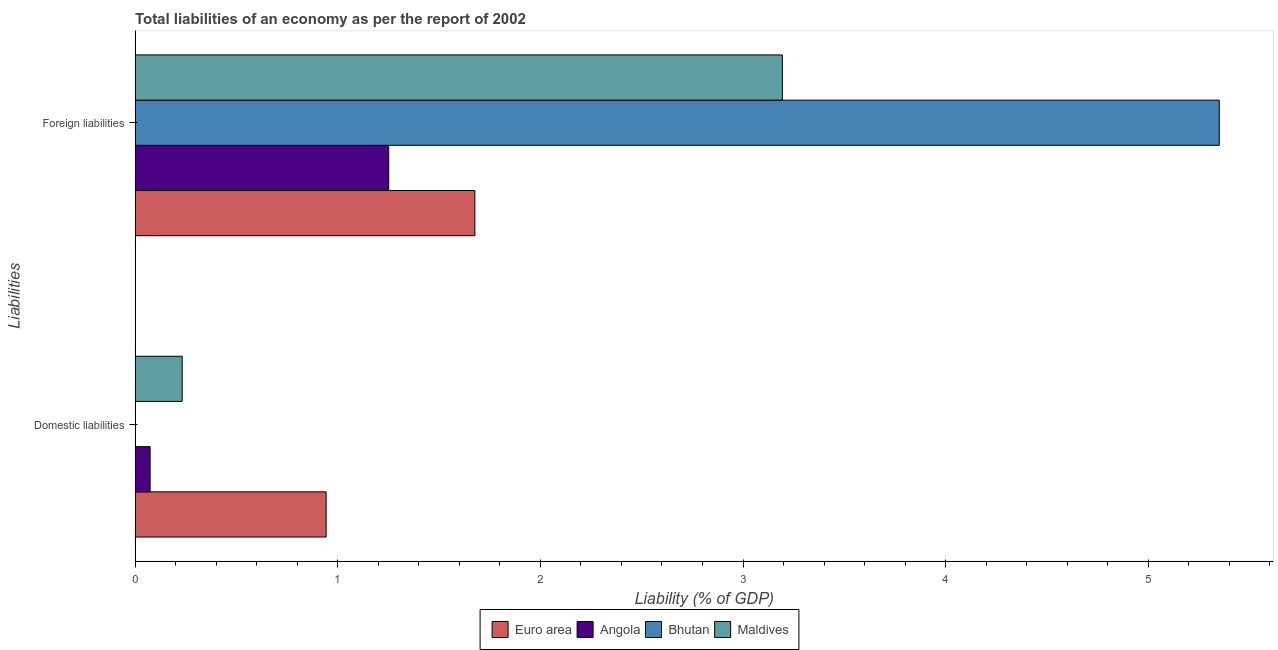Are the number of bars on each tick of the Y-axis equal?
Offer a terse response. No. What is the label of the 2nd group of bars from the top?
Your response must be concise. Domestic liabilities. What is the incurrence of foreign liabilities in Bhutan?
Your answer should be very brief. 5.35. Across all countries, what is the maximum incurrence of foreign liabilities?
Provide a succinct answer. 5.35. Across all countries, what is the minimum incurrence of foreign liabilities?
Ensure brevity in your answer.  1.25. In which country was the incurrence of foreign liabilities maximum?
Your answer should be compact. Bhutan. What is the total incurrence of foreign liabilities in the graph?
Your answer should be compact. 11.47. What is the difference between the incurrence of foreign liabilities in Bhutan and that in Maldives?
Provide a short and direct response. 2.16. What is the difference between the incurrence of domestic liabilities in Maldives and the incurrence of foreign liabilities in Bhutan?
Offer a terse response. -5.12. What is the average incurrence of foreign liabilities per country?
Make the answer very short. 2.87. What is the difference between the incurrence of domestic liabilities and incurrence of foreign liabilities in Angola?
Your answer should be very brief. -1.18. In how many countries, is the incurrence of domestic liabilities greater than 3.4 %?
Offer a very short reply. 0. What is the ratio of the incurrence of foreign liabilities in Bhutan to that in Angola?
Your answer should be very brief. 4.27. In how many countries, is the incurrence of domestic liabilities greater than the average incurrence of domestic liabilities taken over all countries?
Provide a short and direct response. 1. Are the values on the major ticks of X-axis written in scientific E-notation?
Your answer should be compact. No. Does the graph contain any zero values?
Offer a terse response. Yes. Where does the legend appear in the graph?
Provide a succinct answer. Bottom center. How many legend labels are there?
Provide a short and direct response. 4. What is the title of the graph?
Offer a terse response. Total liabilities of an economy as per the report of 2002. Does "Tanzania" appear as one of the legend labels in the graph?
Your answer should be very brief. No. What is the label or title of the X-axis?
Give a very brief answer. Liability (% of GDP). What is the label or title of the Y-axis?
Offer a very short reply. Liabilities. What is the Liability (% of GDP) of Euro area in Domestic liabilities?
Provide a succinct answer. 0.94. What is the Liability (% of GDP) in Angola in Domestic liabilities?
Give a very brief answer. 0.07. What is the Liability (% of GDP) of Bhutan in Domestic liabilities?
Offer a terse response. 0. What is the Liability (% of GDP) in Maldives in Domestic liabilities?
Your answer should be compact. 0.23. What is the Liability (% of GDP) of Euro area in Foreign liabilities?
Offer a terse response. 1.68. What is the Liability (% of GDP) of Angola in Foreign liabilities?
Keep it short and to the point. 1.25. What is the Liability (% of GDP) of Bhutan in Foreign liabilities?
Offer a very short reply. 5.35. What is the Liability (% of GDP) in Maldives in Foreign liabilities?
Offer a terse response. 3.19. Across all Liabilities, what is the maximum Liability (% of GDP) in Euro area?
Make the answer very short. 1.68. Across all Liabilities, what is the maximum Liability (% of GDP) of Angola?
Give a very brief answer. 1.25. Across all Liabilities, what is the maximum Liability (% of GDP) in Bhutan?
Give a very brief answer. 5.35. Across all Liabilities, what is the maximum Liability (% of GDP) of Maldives?
Provide a short and direct response. 3.19. Across all Liabilities, what is the minimum Liability (% of GDP) of Euro area?
Ensure brevity in your answer.  0.94. Across all Liabilities, what is the minimum Liability (% of GDP) in Angola?
Give a very brief answer. 0.07. Across all Liabilities, what is the minimum Liability (% of GDP) of Bhutan?
Offer a very short reply. 0. Across all Liabilities, what is the minimum Liability (% of GDP) in Maldives?
Provide a succinct answer. 0.23. What is the total Liability (% of GDP) in Euro area in the graph?
Give a very brief answer. 2.62. What is the total Liability (% of GDP) of Angola in the graph?
Provide a short and direct response. 1.33. What is the total Liability (% of GDP) in Bhutan in the graph?
Keep it short and to the point. 5.35. What is the total Liability (% of GDP) of Maldives in the graph?
Offer a terse response. 3.43. What is the difference between the Liability (% of GDP) in Euro area in Domestic liabilities and that in Foreign liabilities?
Provide a succinct answer. -0.73. What is the difference between the Liability (% of GDP) in Angola in Domestic liabilities and that in Foreign liabilities?
Offer a very short reply. -1.18. What is the difference between the Liability (% of GDP) of Maldives in Domestic liabilities and that in Foreign liabilities?
Your response must be concise. -2.96. What is the difference between the Liability (% of GDP) in Euro area in Domestic liabilities and the Liability (% of GDP) in Angola in Foreign liabilities?
Offer a very short reply. -0.31. What is the difference between the Liability (% of GDP) in Euro area in Domestic liabilities and the Liability (% of GDP) in Bhutan in Foreign liabilities?
Provide a short and direct response. -4.41. What is the difference between the Liability (% of GDP) of Euro area in Domestic liabilities and the Liability (% of GDP) of Maldives in Foreign liabilities?
Keep it short and to the point. -2.25. What is the difference between the Liability (% of GDP) of Angola in Domestic liabilities and the Liability (% of GDP) of Bhutan in Foreign liabilities?
Give a very brief answer. -5.28. What is the difference between the Liability (% of GDP) in Angola in Domestic liabilities and the Liability (% of GDP) in Maldives in Foreign liabilities?
Ensure brevity in your answer.  -3.12. What is the average Liability (% of GDP) of Euro area per Liabilities?
Make the answer very short. 1.31. What is the average Liability (% of GDP) of Angola per Liabilities?
Offer a very short reply. 0.66. What is the average Liability (% of GDP) in Bhutan per Liabilities?
Your answer should be compact. 2.67. What is the average Liability (% of GDP) of Maldives per Liabilities?
Keep it short and to the point. 1.71. What is the difference between the Liability (% of GDP) in Euro area and Liability (% of GDP) in Angola in Domestic liabilities?
Your answer should be very brief. 0.87. What is the difference between the Liability (% of GDP) of Euro area and Liability (% of GDP) of Maldives in Domestic liabilities?
Make the answer very short. 0.71. What is the difference between the Liability (% of GDP) of Angola and Liability (% of GDP) of Maldives in Domestic liabilities?
Offer a terse response. -0.16. What is the difference between the Liability (% of GDP) in Euro area and Liability (% of GDP) in Angola in Foreign liabilities?
Offer a terse response. 0.43. What is the difference between the Liability (% of GDP) of Euro area and Liability (% of GDP) of Bhutan in Foreign liabilities?
Keep it short and to the point. -3.67. What is the difference between the Liability (% of GDP) of Euro area and Liability (% of GDP) of Maldives in Foreign liabilities?
Your answer should be very brief. -1.52. What is the difference between the Liability (% of GDP) in Angola and Liability (% of GDP) in Bhutan in Foreign liabilities?
Your response must be concise. -4.1. What is the difference between the Liability (% of GDP) in Angola and Liability (% of GDP) in Maldives in Foreign liabilities?
Provide a succinct answer. -1.94. What is the difference between the Liability (% of GDP) in Bhutan and Liability (% of GDP) in Maldives in Foreign liabilities?
Your response must be concise. 2.16. What is the ratio of the Liability (% of GDP) of Euro area in Domestic liabilities to that in Foreign liabilities?
Your answer should be very brief. 0.56. What is the ratio of the Liability (% of GDP) of Angola in Domestic liabilities to that in Foreign liabilities?
Your answer should be compact. 0.06. What is the ratio of the Liability (% of GDP) of Maldives in Domestic liabilities to that in Foreign liabilities?
Offer a terse response. 0.07. What is the difference between the highest and the second highest Liability (% of GDP) in Euro area?
Provide a succinct answer. 0.73. What is the difference between the highest and the second highest Liability (% of GDP) of Angola?
Provide a succinct answer. 1.18. What is the difference between the highest and the second highest Liability (% of GDP) of Maldives?
Offer a terse response. 2.96. What is the difference between the highest and the lowest Liability (% of GDP) in Euro area?
Provide a short and direct response. 0.73. What is the difference between the highest and the lowest Liability (% of GDP) in Angola?
Keep it short and to the point. 1.18. What is the difference between the highest and the lowest Liability (% of GDP) in Bhutan?
Offer a terse response. 5.35. What is the difference between the highest and the lowest Liability (% of GDP) in Maldives?
Offer a terse response. 2.96. 